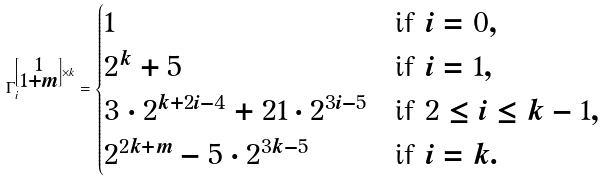<formula> <loc_0><loc_0><loc_500><loc_500>\Gamma _ { i } ^ { \left [ \substack { 1 \\ 1 + m } \right ] \times k } = \begin{cases} 1 & \text {if } i = 0 , \\ 2 ^ { k } + 5 & \text {if } i = 1 , \\ 3 \cdot 2 ^ { k + 2 i - 4 } + 2 1 \cdot 2 ^ { 3 i - 5 } & \text {if  } 2 \leq i \leq k - 1 , \\ 2 ^ { 2 k + m } - 5 \cdot 2 ^ { 3 k - 5 } & \text {if  } i = k . \end{cases}</formula> 